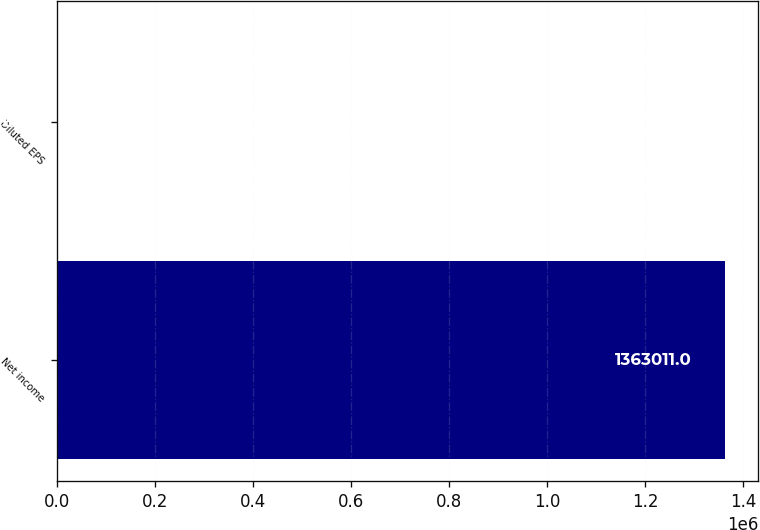<chart> <loc_0><loc_0><loc_500><loc_500><bar_chart><fcel>Net income<fcel>Diluted EPS<nl><fcel>1.36301e+06<fcel>3.65<nl></chart> 